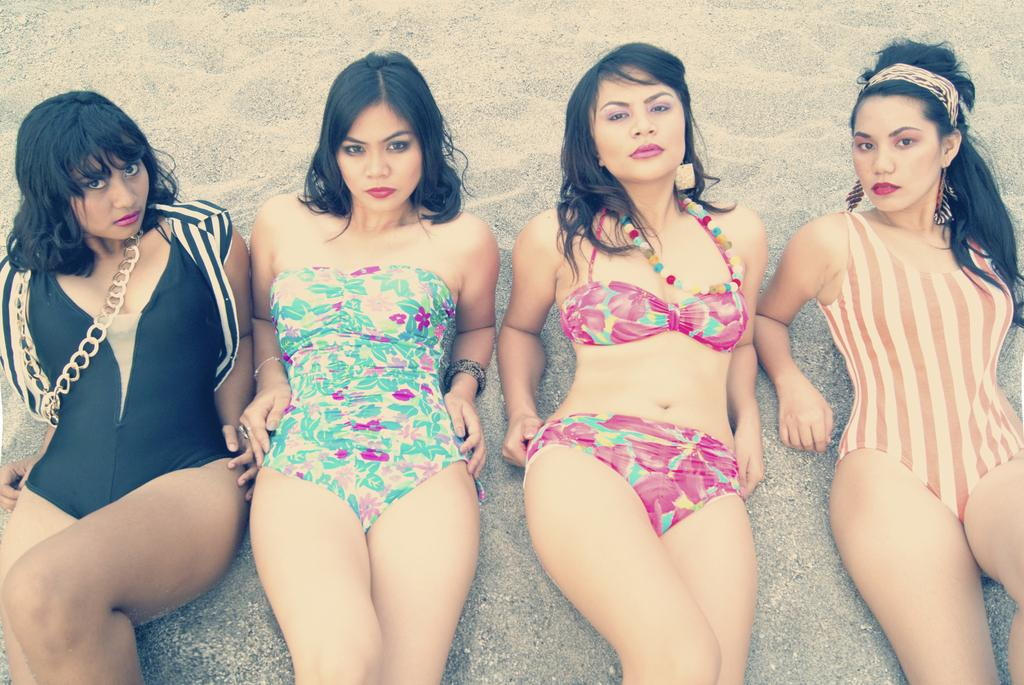What is the main subject of the image? The main subject of the image is a group of women. What are the women doing in the image? The women are laying on the ground. What type of surface is the ground covered with? The ground is covered with sand. What type of territory does the creator of the image claim in the image? There is no reference to a creator or territory in the image, so it is not possible to answer that question. 